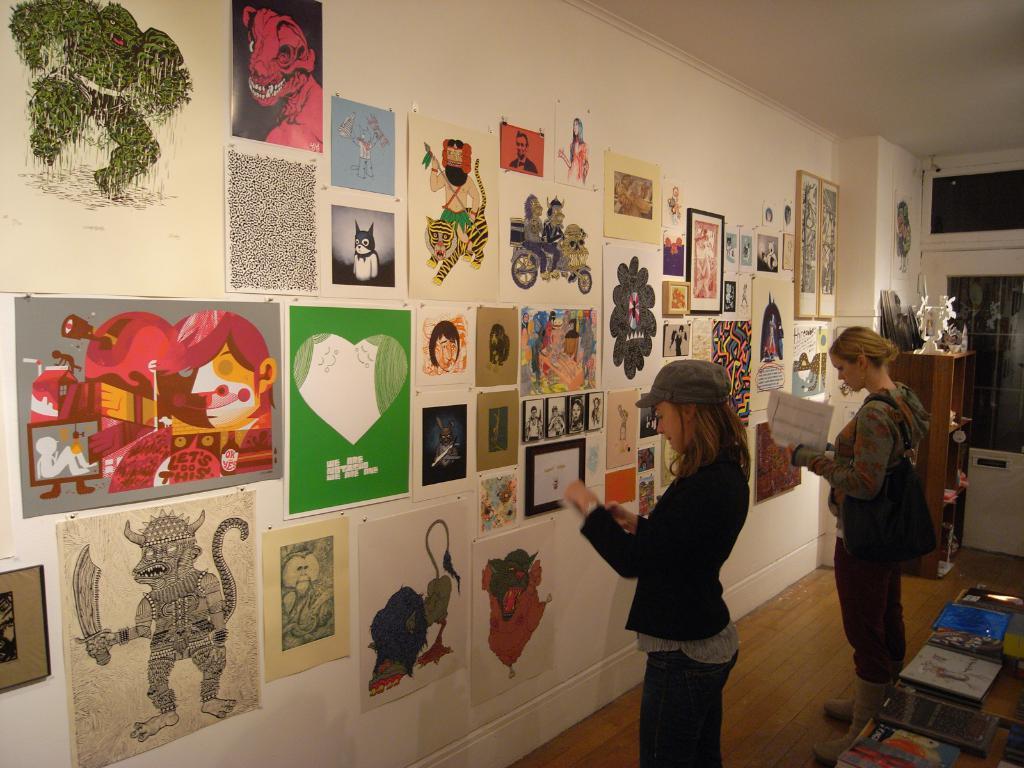How would you summarize this image in a sentence or two? In the image in the center,we can see two persons were standing and they were holding some objects. On the right bottom of the image we can see frames etc. In the background there is a wall,roof,window,table,sculpture,posters,photo frames and few other objects. 